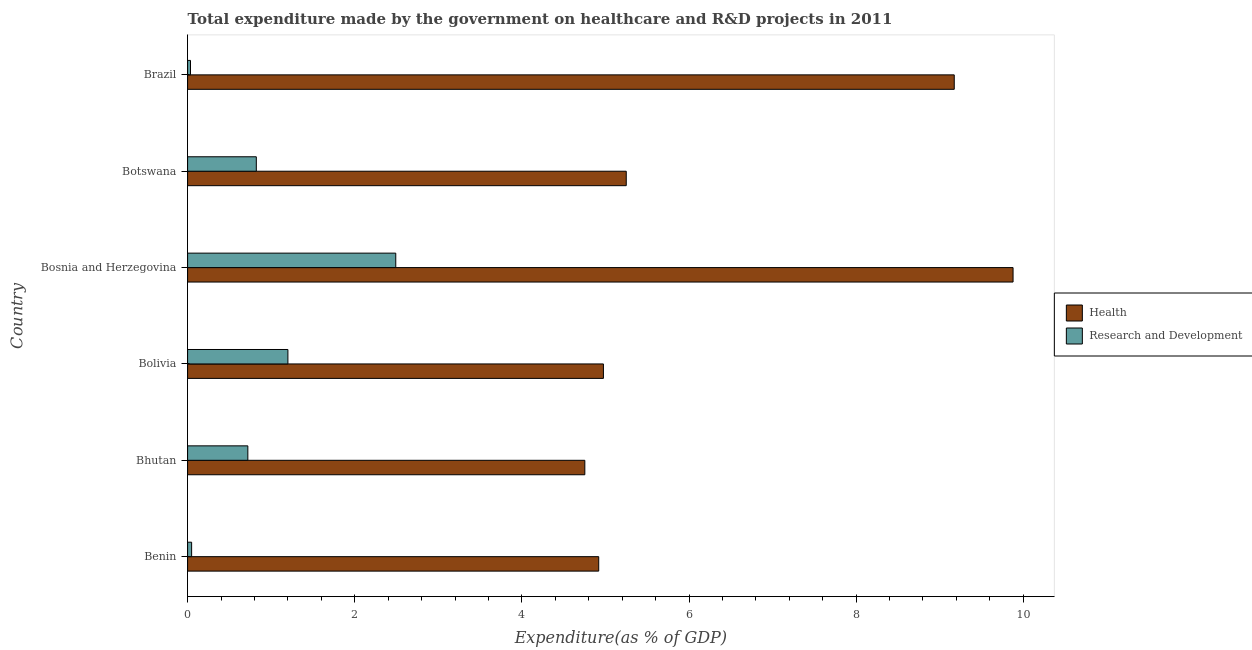How many different coloured bars are there?
Ensure brevity in your answer.  2. How many groups of bars are there?
Give a very brief answer. 6. What is the label of the 5th group of bars from the top?
Your answer should be compact. Bhutan. In how many cases, is the number of bars for a given country not equal to the number of legend labels?
Offer a very short reply. 0. What is the expenditure in healthcare in Botswana?
Give a very brief answer. 5.25. Across all countries, what is the maximum expenditure in healthcare?
Your response must be concise. 9.88. Across all countries, what is the minimum expenditure in r&d?
Provide a short and direct response. 0.03. In which country was the expenditure in healthcare maximum?
Your response must be concise. Bosnia and Herzegovina. What is the total expenditure in r&d in the graph?
Your answer should be very brief. 5.32. What is the difference between the expenditure in healthcare in Botswana and that in Brazil?
Keep it short and to the point. -3.92. What is the difference between the expenditure in r&d in Bhutan and the expenditure in healthcare in Brazil?
Provide a short and direct response. -8.45. What is the average expenditure in healthcare per country?
Give a very brief answer. 6.49. What is the difference between the expenditure in r&d and expenditure in healthcare in Brazil?
Keep it short and to the point. -9.14. What is the ratio of the expenditure in r&d in Bhutan to that in Brazil?
Offer a terse response. 20.74. Is the difference between the expenditure in healthcare in Bhutan and Bolivia greater than the difference between the expenditure in r&d in Bhutan and Bolivia?
Provide a succinct answer. Yes. What is the difference between the highest and the second highest expenditure in healthcare?
Your response must be concise. 0.7. What is the difference between the highest and the lowest expenditure in healthcare?
Provide a succinct answer. 5.12. In how many countries, is the expenditure in healthcare greater than the average expenditure in healthcare taken over all countries?
Provide a succinct answer. 2. What does the 2nd bar from the top in Benin represents?
Keep it short and to the point. Health. What does the 1st bar from the bottom in Brazil represents?
Your response must be concise. Health. How many bars are there?
Your answer should be compact. 12. Are all the bars in the graph horizontal?
Your response must be concise. Yes. How many countries are there in the graph?
Offer a terse response. 6. Does the graph contain grids?
Provide a short and direct response. No. How many legend labels are there?
Ensure brevity in your answer.  2. How are the legend labels stacked?
Offer a very short reply. Vertical. What is the title of the graph?
Provide a succinct answer. Total expenditure made by the government on healthcare and R&D projects in 2011. What is the label or title of the X-axis?
Offer a terse response. Expenditure(as % of GDP). What is the Expenditure(as % of GDP) in Health in Benin?
Make the answer very short. 4.92. What is the Expenditure(as % of GDP) in Research and Development in Benin?
Ensure brevity in your answer.  0.05. What is the Expenditure(as % of GDP) in Health in Bhutan?
Offer a very short reply. 4.75. What is the Expenditure(as % of GDP) in Research and Development in Bhutan?
Provide a short and direct response. 0.72. What is the Expenditure(as % of GDP) of Health in Bolivia?
Keep it short and to the point. 4.98. What is the Expenditure(as % of GDP) in Research and Development in Bolivia?
Keep it short and to the point. 1.2. What is the Expenditure(as % of GDP) of Health in Bosnia and Herzegovina?
Your answer should be compact. 9.88. What is the Expenditure(as % of GDP) of Research and Development in Bosnia and Herzegovina?
Provide a short and direct response. 2.49. What is the Expenditure(as % of GDP) of Health in Botswana?
Your answer should be very brief. 5.25. What is the Expenditure(as % of GDP) of Research and Development in Botswana?
Make the answer very short. 0.82. What is the Expenditure(as % of GDP) in Health in Brazil?
Offer a terse response. 9.17. What is the Expenditure(as % of GDP) of Research and Development in Brazil?
Provide a short and direct response. 0.03. Across all countries, what is the maximum Expenditure(as % of GDP) in Health?
Give a very brief answer. 9.88. Across all countries, what is the maximum Expenditure(as % of GDP) of Research and Development?
Keep it short and to the point. 2.49. Across all countries, what is the minimum Expenditure(as % of GDP) in Health?
Provide a short and direct response. 4.75. Across all countries, what is the minimum Expenditure(as % of GDP) of Research and Development?
Your response must be concise. 0.03. What is the total Expenditure(as % of GDP) of Health in the graph?
Provide a succinct answer. 38.95. What is the total Expenditure(as % of GDP) of Research and Development in the graph?
Ensure brevity in your answer.  5.32. What is the difference between the Expenditure(as % of GDP) in Health in Benin and that in Bhutan?
Provide a succinct answer. 0.17. What is the difference between the Expenditure(as % of GDP) of Research and Development in Benin and that in Bhutan?
Keep it short and to the point. -0.67. What is the difference between the Expenditure(as % of GDP) in Health in Benin and that in Bolivia?
Provide a short and direct response. -0.06. What is the difference between the Expenditure(as % of GDP) of Research and Development in Benin and that in Bolivia?
Keep it short and to the point. -1.15. What is the difference between the Expenditure(as % of GDP) in Health in Benin and that in Bosnia and Herzegovina?
Your answer should be compact. -4.96. What is the difference between the Expenditure(as % of GDP) in Research and Development in Benin and that in Bosnia and Herzegovina?
Give a very brief answer. -2.44. What is the difference between the Expenditure(as % of GDP) of Health in Benin and that in Botswana?
Your answer should be very brief. -0.33. What is the difference between the Expenditure(as % of GDP) in Research and Development in Benin and that in Botswana?
Your answer should be compact. -0.77. What is the difference between the Expenditure(as % of GDP) of Health in Benin and that in Brazil?
Your response must be concise. -4.25. What is the difference between the Expenditure(as % of GDP) in Research and Development in Benin and that in Brazil?
Provide a short and direct response. 0.01. What is the difference between the Expenditure(as % of GDP) in Health in Bhutan and that in Bolivia?
Ensure brevity in your answer.  -0.22. What is the difference between the Expenditure(as % of GDP) in Research and Development in Bhutan and that in Bolivia?
Make the answer very short. -0.48. What is the difference between the Expenditure(as % of GDP) in Health in Bhutan and that in Bosnia and Herzegovina?
Your answer should be compact. -5.12. What is the difference between the Expenditure(as % of GDP) in Research and Development in Bhutan and that in Bosnia and Herzegovina?
Provide a short and direct response. -1.77. What is the difference between the Expenditure(as % of GDP) in Health in Bhutan and that in Botswana?
Offer a terse response. -0.5. What is the difference between the Expenditure(as % of GDP) in Research and Development in Bhutan and that in Botswana?
Provide a short and direct response. -0.1. What is the difference between the Expenditure(as % of GDP) of Health in Bhutan and that in Brazil?
Your response must be concise. -4.42. What is the difference between the Expenditure(as % of GDP) of Research and Development in Bhutan and that in Brazil?
Offer a terse response. 0.69. What is the difference between the Expenditure(as % of GDP) in Health in Bolivia and that in Bosnia and Herzegovina?
Make the answer very short. -4.9. What is the difference between the Expenditure(as % of GDP) of Research and Development in Bolivia and that in Bosnia and Herzegovina?
Make the answer very short. -1.29. What is the difference between the Expenditure(as % of GDP) of Health in Bolivia and that in Botswana?
Keep it short and to the point. -0.27. What is the difference between the Expenditure(as % of GDP) in Research and Development in Bolivia and that in Botswana?
Your answer should be very brief. 0.38. What is the difference between the Expenditure(as % of GDP) of Health in Bolivia and that in Brazil?
Keep it short and to the point. -4.2. What is the difference between the Expenditure(as % of GDP) in Research and Development in Bolivia and that in Brazil?
Your answer should be compact. 1.17. What is the difference between the Expenditure(as % of GDP) of Health in Bosnia and Herzegovina and that in Botswana?
Keep it short and to the point. 4.63. What is the difference between the Expenditure(as % of GDP) in Research and Development in Bosnia and Herzegovina and that in Botswana?
Your answer should be compact. 1.67. What is the difference between the Expenditure(as % of GDP) in Health in Bosnia and Herzegovina and that in Brazil?
Offer a terse response. 0.7. What is the difference between the Expenditure(as % of GDP) in Research and Development in Bosnia and Herzegovina and that in Brazil?
Your response must be concise. 2.46. What is the difference between the Expenditure(as % of GDP) in Health in Botswana and that in Brazil?
Ensure brevity in your answer.  -3.92. What is the difference between the Expenditure(as % of GDP) in Research and Development in Botswana and that in Brazil?
Provide a succinct answer. 0.79. What is the difference between the Expenditure(as % of GDP) of Health in Benin and the Expenditure(as % of GDP) of Research and Development in Bhutan?
Your response must be concise. 4.2. What is the difference between the Expenditure(as % of GDP) in Health in Benin and the Expenditure(as % of GDP) in Research and Development in Bolivia?
Provide a succinct answer. 3.72. What is the difference between the Expenditure(as % of GDP) of Health in Benin and the Expenditure(as % of GDP) of Research and Development in Bosnia and Herzegovina?
Keep it short and to the point. 2.43. What is the difference between the Expenditure(as % of GDP) in Health in Benin and the Expenditure(as % of GDP) in Research and Development in Botswana?
Make the answer very short. 4.1. What is the difference between the Expenditure(as % of GDP) of Health in Benin and the Expenditure(as % of GDP) of Research and Development in Brazil?
Provide a short and direct response. 4.88. What is the difference between the Expenditure(as % of GDP) of Health in Bhutan and the Expenditure(as % of GDP) of Research and Development in Bolivia?
Your answer should be very brief. 3.55. What is the difference between the Expenditure(as % of GDP) in Health in Bhutan and the Expenditure(as % of GDP) in Research and Development in Bosnia and Herzegovina?
Provide a short and direct response. 2.26. What is the difference between the Expenditure(as % of GDP) in Health in Bhutan and the Expenditure(as % of GDP) in Research and Development in Botswana?
Make the answer very short. 3.93. What is the difference between the Expenditure(as % of GDP) of Health in Bhutan and the Expenditure(as % of GDP) of Research and Development in Brazil?
Give a very brief answer. 4.72. What is the difference between the Expenditure(as % of GDP) of Health in Bolivia and the Expenditure(as % of GDP) of Research and Development in Bosnia and Herzegovina?
Provide a short and direct response. 2.48. What is the difference between the Expenditure(as % of GDP) of Health in Bolivia and the Expenditure(as % of GDP) of Research and Development in Botswana?
Offer a very short reply. 4.15. What is the difference between the Expenditure(as % of GDP) of Health in Bolivia and the Expenditure(as % of GDP) of Research and Development in Brazil?
Ensure brevity in your answer.  4.94. What is the difference between the Expenditure(as % of GDP) of Health in Bosnia and Herzegovina and the Expenditure(as % of GDP) of Research and Development in Botswana?
Your answer should be very brief. 9.06. What is the difference between the Expenditure(as % of GDP) in Health in Bosnia and Herzegovina and the Expenditure(as % of GDP) in Research and Development in Brazil?
Offer a very short reply. 9.84. What is the difference between the Expenditure(as % of GDP) in Health in Botswana and the Expenditure(as % of GDP) in Research and Development in Brazil?
Provide a succinct answer. 5.21. What is the average Expenditure(as % of GDP) of Health per country?
Offer a very short reply. 6.49. What is the average Expenditure(as % of GDP) in Research and Development per country?
Your response must be concise. 0.89. What is the difference between the Expenditure(as % of GDP) in Health and Expenditure(as % of GDP) in Research and Development in Benin?
Provide a succinct answer. 4.87. What is the difference between the Expenditure(as % of GDP) in Health and Expenditure(as % of GDP) in Research and Development in Bhutan?
Give a very brief answer. 4.03. What is the difference between the Expenditure(as % of GDP) of Health and Expenditure(as % of GDP) of Research and Development in Bolivia?
Make the answer very short. 3.78. What is the difference between the Expenditure(as % of GDP) of Health and Expenditure(as % of GDP) of Research and Development in Bosnia and Herzegovina?
Your response must be concise. 7.39. What is the difference between the Expenditure(as % of GDP) in Health and Expenditure(as % of GDP) in Research and Development in Botswana?
Offer a very short reply. 4.43. What is the difference between the Expenditure(as % of GDP) of Health and Expenditure(as % of GDP) of Research and Development in Brazil?
Your answer should be very brief. 9.14. What is the ratio of the Expenditure(as % of GDP) of Health in Benin to that in Bhutan?
Make the answer very short. 1.03. What is the ratio of the Expenditure(as % of GDP) in Research and Development in Benin to that in Bhutan?
Provide a short and direct response. 0.07. What is the ratio of the Expenditure(as % of GDP) of Health in Benin to that in Bolivia?
Give a very brief answer. 0.99. What is the ratio of the Expenditure(as % of GDP) in Research and Development in Benin to that in Bolivia?
Give a very brief answer. 0.04. What is the ratio of the Expenditure(as % of GDP) in Health in Benin to that in Bosnia and Herzegovina?
Offer a terse response. 0.5. What is the ratio of the Expenditure(as % of GDP) of Research and Development in Benin to that in Bosnia and Herzegovina?
Your answer should be very brief. 0.02. What is the ratio of the Expenditure(as % of GDP) of Health in Benin to that in Botswana?
Give a very brief answer. 0.94. What is the ratio of the Expenditure(as % of GDP) of Research and Development in Benin to that in Botswana?
Your answer should be compact. 0.06. What is the ratio of the Expenditure(as % of GDP) of Health in Benin to that in Brazil?
Your answer should be very brief. 0.54. What is the ratio of the Expenditure(as % of GDP) in Research and Development in Benin to that in Brazil?
Make the answer very short. 1.38. What is the ratio of the Expenditure(as % of GDP) in Health in Bhutan to that in Bolivia?
Keep it short and to the point. 0.96. What is the ratio of the Expenditure(as % of GDP) of Research and Development in Bhutan to that in Bolivia?
Give a very brief answer. 0.6. What is the ratio of the Expenditure(as % of GDP) of Health in Bhutan to that in Bosnia and Herzegovina?
Provide a short and direct response. 0.48. What is the ratio of the Expenditure(as % of GDP) of Research and Development in Bhutan to that in Bosnia and Herzegovina?
Offer a very short reply. 0.29. What is the ratio of the Expenditure(as % of GDP) of Health in Bhutan to that in Botswana?
Make the answer very short. 0.91. What is the ratio of the Expenditure(as % of GDP) in Research and Development in Bhutan to that in Botswana?
Your response must be concise. 0.88. What is the ratio of the Expenditure(as % of GDP) in Health in Bhutan to that in Brazil?
Your answer should be very brief. 0.52. What is the ratio of the Expenditure(as % of GDP) of Research and Development in Bhutan to that in Brazil?
Your answer should be very brief. 20.74. What is the ratio of the Expenditure(as % of GDP) of Health in Bolivia to that in Bosnia and Herzegovina?
Give a very brief answer. 0.5. What is the ratio of the Expenditure(as % of GDP) in Research and Development in Bolivia to that in Bosnia and Herzegovina?
Offer a very short reply. 0.48. What is the ratio of the Expenditure(as % of GDP) of Health in Bolivia to that in Botswana?
Offer a terse response. 0.95. What is the ratio of the Expenditure(as % of GDP) in Research and Development in Bolivia to that in Botswana?
Offer a very short reply. 1.46. What is the ratio of the Expenditure(as % of GDP) in Health in Bolivia to that in Brazil?
Keep it short and to the point. 0.54. What is the ratio of the Expenditure(as % of GDP) in Research and Development in Bolivia to that in Brazil?
Give a very brief answer. 34.53. What is the ratio of the Expenditure(as % of GDP) in Health in Bosnia and Herzegovina to that in Botswana?
Offer a very short reply. 1.88. What is the ratio of the Expenditure(as % of GDP) of Research and Development in Bosnia and Herzegovina to that in Botswana?
Offer a terse response. 3.03. What is the ratio of the Expenditure(as % of GDP) in Health in Bosnia and Herzegovina to that in Brazil?
Ensure brevity in your answer.  1.08. What is the ratio of the Expenditure(as % of GDP) of Research and Development in Bosnia and Herzegovina to that in Brazil?
Provide a short and direct response. 71.66. What is the ratio of the Expenditure(as % of GDP) in Health in Botswana to that in Brazil?
Your response must be concise. 0.57. What is the ratio of the Expenditure(as % of GDP) in Research and Development in Botswana to that in Brazil?
Your answer should be very brief. 23.65. What is the difference between the highest and the second highest Expenditure(as % of GDP) of Health?
Provide a short and direct response. 0.7. What is the difference between the highest and the second highest Expenditure(as % of GDP) of Research and Development?
Your response must be concise. 1.29. What is the difference between the highest and the lowest Expenditure(as % of GDP) in Health?
Keep it short and to the point. 5.12. What is the difference between the highest and the lowest Expenditure(as % of GDP) of Research and Development?
Give a very brief answer. 2.46. 